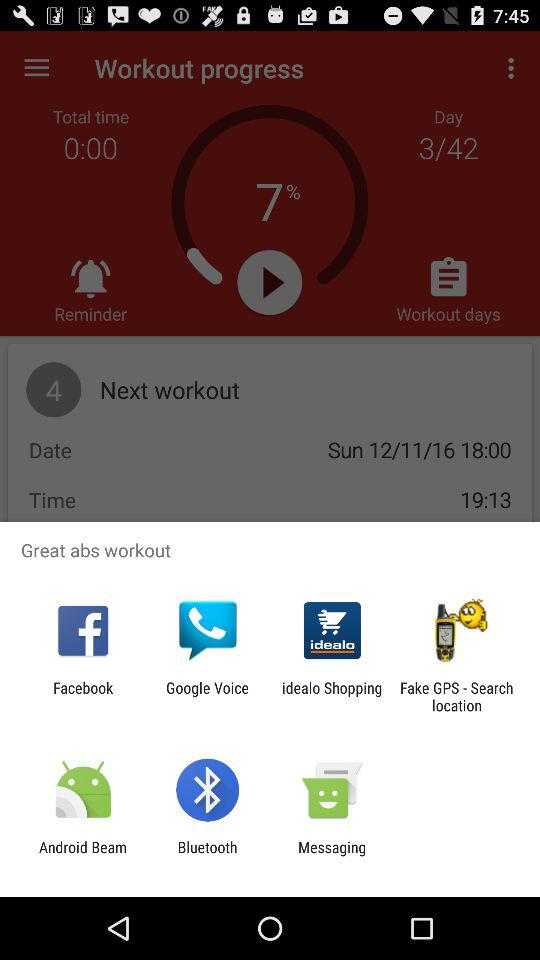What is the name of the workout?
Answer the question using a single word or phrase. Great abs workout 